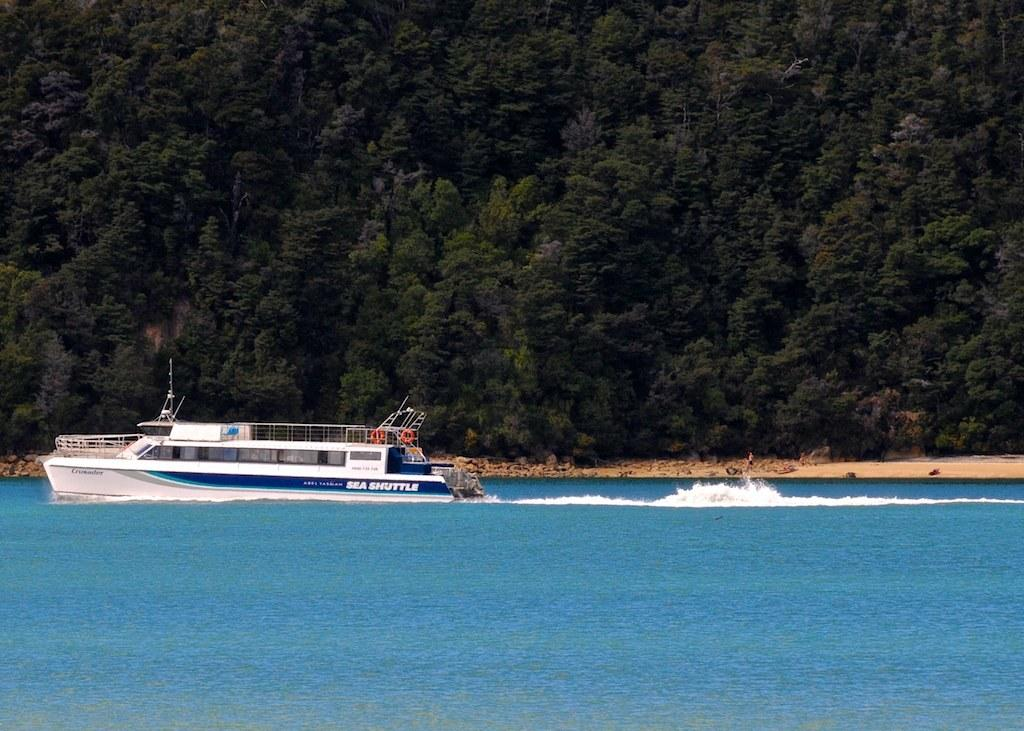What is the main subject of the image? There is a ship in the image. Can you describe the ship's position in relation to the water? The ship is above the water. What can be seen in the background of the image? There are trees visible in the background of the image. What type of arch can be seen supporting the ship in the image? There is no arch present in the image; the ship is above the water without any visible support. 